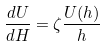Convert formula to latex. <formula><loc_0><loc_0><loc_500><loc_500>\frac { d U } { d H } = \zeta \frac { U ( h ) } { h }</formula> 